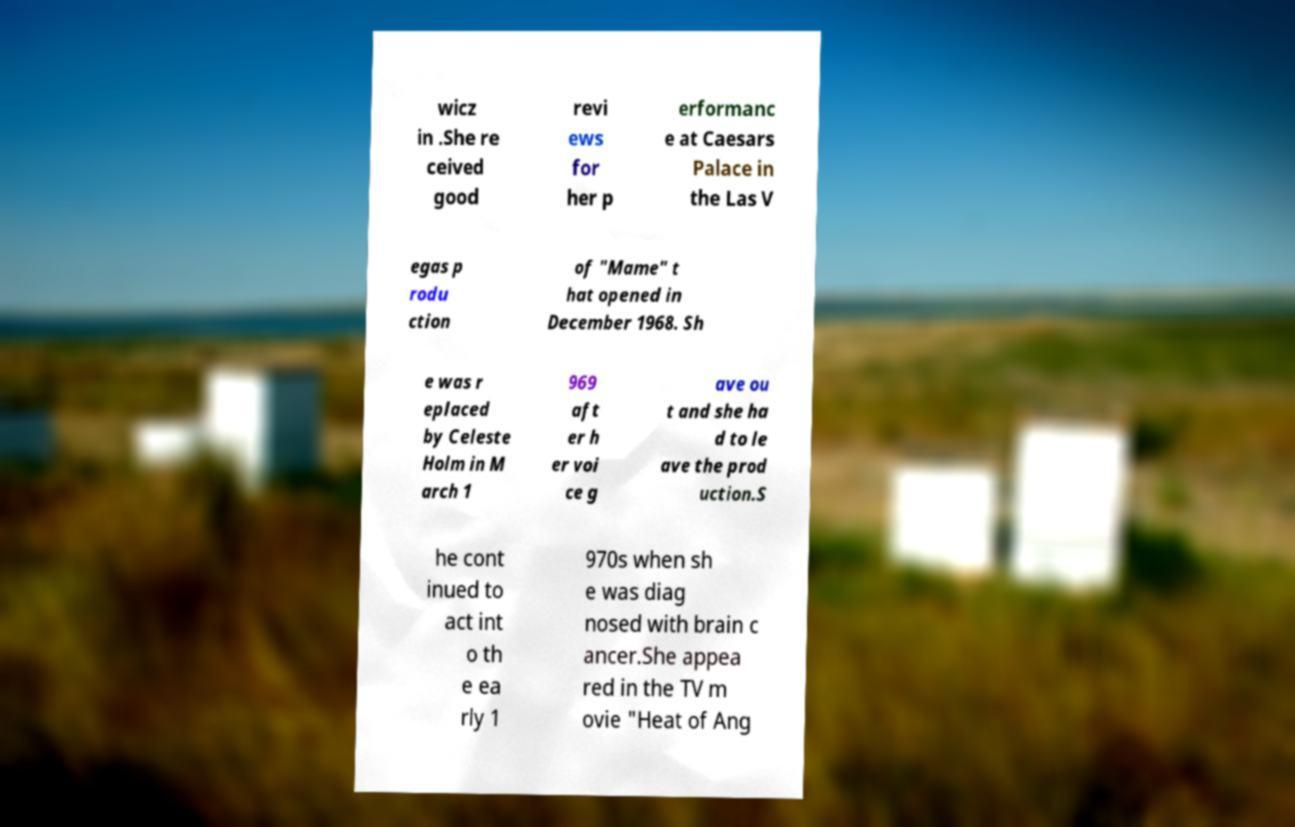Could you extract and type out the text from this image? wicz in .She re ceived good revi ews for her p erformanc e at Caesars Palace in the Las V egas p rodu ction of "Mame" t hat opened in December 1968. Sh e was r eplaced by Celeste Holm in M arch 1 969 aft er h er voi ce g ave ou t and she ha d to le ave the prod uction.S he cont inued to act int o th e ea rly 1 970s when sh e was diag nosed with brain c ancer.She appea red in the TV m ovie "Heat of Ang 